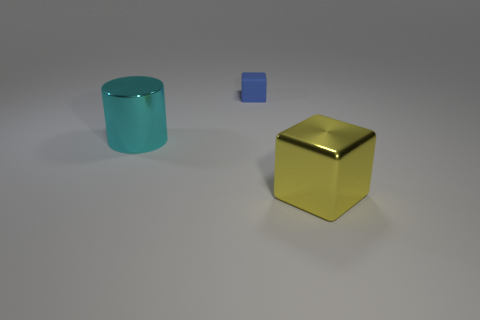Are there any other things that are the same size as the rubber block?
Provide a succinct answer. No. What is the material of the other large yellow thing that is the same shape as the rubber object?
Keep it short and to the point. Metal. The object that is both behind the yellow metallic thing and to the right of the cyan shiny thing is made of what material?
Make the answer very short. Rubber. Are there fewer tiny rubber blocks left of the cyan metallic cylinder than yellow metallic objects left of the large metallic cube?
Make the answer very short. No. What number of other objects are the same size as the cyan metallic thing?
Provide a succinct answer. 1. There is a big object that is left of the block behind the object to the right of the tiny blue matte thing; what shape is it?
Provide a succinct answer. Cylinder. What number of yellow objects are large cylinders or large metallic things?
Provide a succinct answer. 1. How many yellow metallic cubes are in front of the large metal object right of the big cyan thing?
Keep it short and to the point. 0. Is there anything else that has the same color as the large cylinder?
Provide a short and direct response. No. There is a large cyan object that is made of the same material as the large yellow thing; what is its shape?
Offer a terse response. Cylinder. 